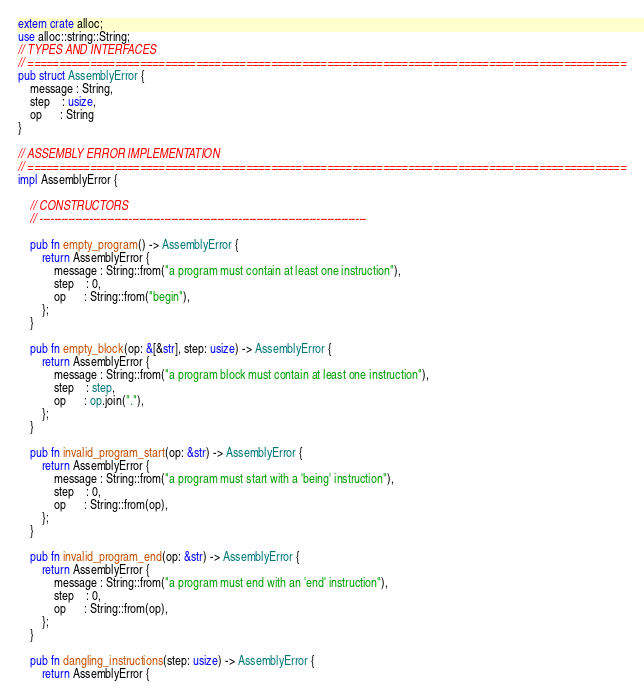Convert code to text. <code><loc_0><loc_0><loc_500><loc_500><_Rust_>extern crate alloc;
use alloc::string::String;
// TYPES AND INTERFACES
// ================================================================================================
pub struct AssemblyError {
    message : String,
    step    : usize,
    op      : String
}

// ASSEMBLY ERROR IMPLEMENTATION
// ================================================================================================
impl AssemblyError {

    // CONSTRUCTORS
    // --------------------------------------------------------------------------------------------

    pub fn empty_program() -> AssemblyError {
        return AssemblyError {
            message : String::from("a program must contain at least one instruction"),
            step    : 0,
            op      : String::from("begin"),
        };
    }

    pub fn empty_block(op: &[&str], step: usize) -> AssemblyError {
        return AssemblyError {
            message : String::from("a program block must contain at least one instruction"),
            step    : step,
            op      : op.join("."),
        };
    }

    pub fn invalid_program_start(op: &str) -> AssemblyError {
        return AssemblyError {
            message : String::from("a program must start with a 'being' instruction"),
            step    : 0,
            op      : String::from(op),
        };
    }

    pub fn invalid_program_end(op: &str) -> AssemblyError {
        return AssemblyError {
            message : String::from("a program must end with an 'end' instruction"),
            step    : 0,
            op      : String::from(op),
        };
    }

    pub fn dangling_instructions(step: usize) -> AssemblyError {
        return AssemblyError {</code> 